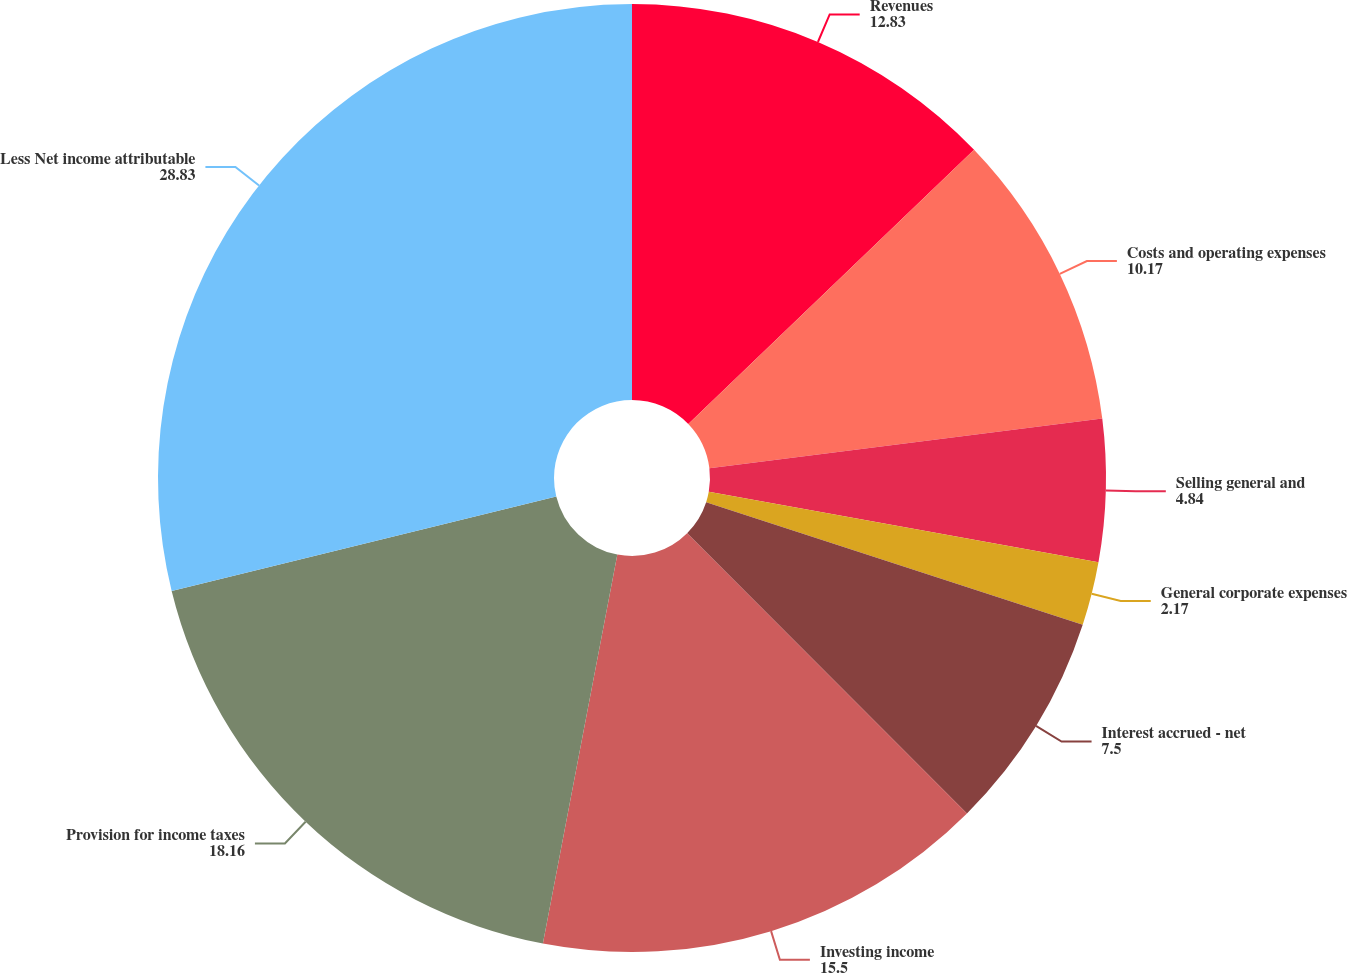Convert chart. <chart><loc_0><loc_0><loc_500><loc_500><pie_chart><fcel>Revenues<fcel>Costs and operating expenses<fcel>Selling general and<fcel>General corporate expenses<fcel>Interest accrued - net<fcel>Investing income<fcel>Provision for income taxes<fcel>Less Net income attributable<nl><fcel>12.83%<fcel>10.17%<fcel>4.84%<fcel>2.17%<fcel>7.5%<fcel>15.5%<fcel>18.16%<fcel>28.83%<nl></chart> 